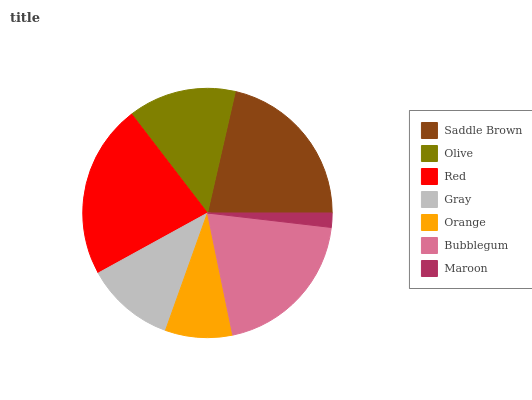Is Maroon the minimum?
Answer yes or no. Yes. Is Red the maximum?
Answer yes or no. Yes. Is Olive the minimum?
Answer yes or no. No. Is Olive the maximum?
Answer yes or no. No. Is Saddle Brown greater than Olive?
Answer yes or no. Yes. Is Olive less than Saddle Brown?
Answer yes or no. Yes. Is Olive greater than Saddle Brown?
Answer yes or no. No. Is Saddle Brown less than Olive?
Answer yes or no. No. Is Olive the high median?
Answer yes or no. Yes. Is Olive the low median?
Answer yes or no. Yes. Is Maroon the high median?
Answer yes or no. No. Is Maroon the low median?
Answer yes or no. No. 